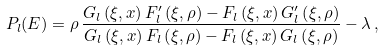<formula> <loc_0><loc_0><loc_500><loc_500>P _ { l } ( E ) = \rho \, \frac { G _ { l } \left ( \xi , x \right ) F _ { l } ^ { \prime } \left ( \xi , \rho \right ) - F _ { l } \left ( \xi , x \right ) G _ { l } ^ { \prime } \left ( \xi , \rho \right ) } { G _ { l } \left ( \xi , x \right ) F _ { l } \left ( \xi , \rho \right ) - F _ { l } \left ( \xi , x \right ) G _ { l } \left ( \xi , \rho \right ) } - \lambda \, ,</formula> 